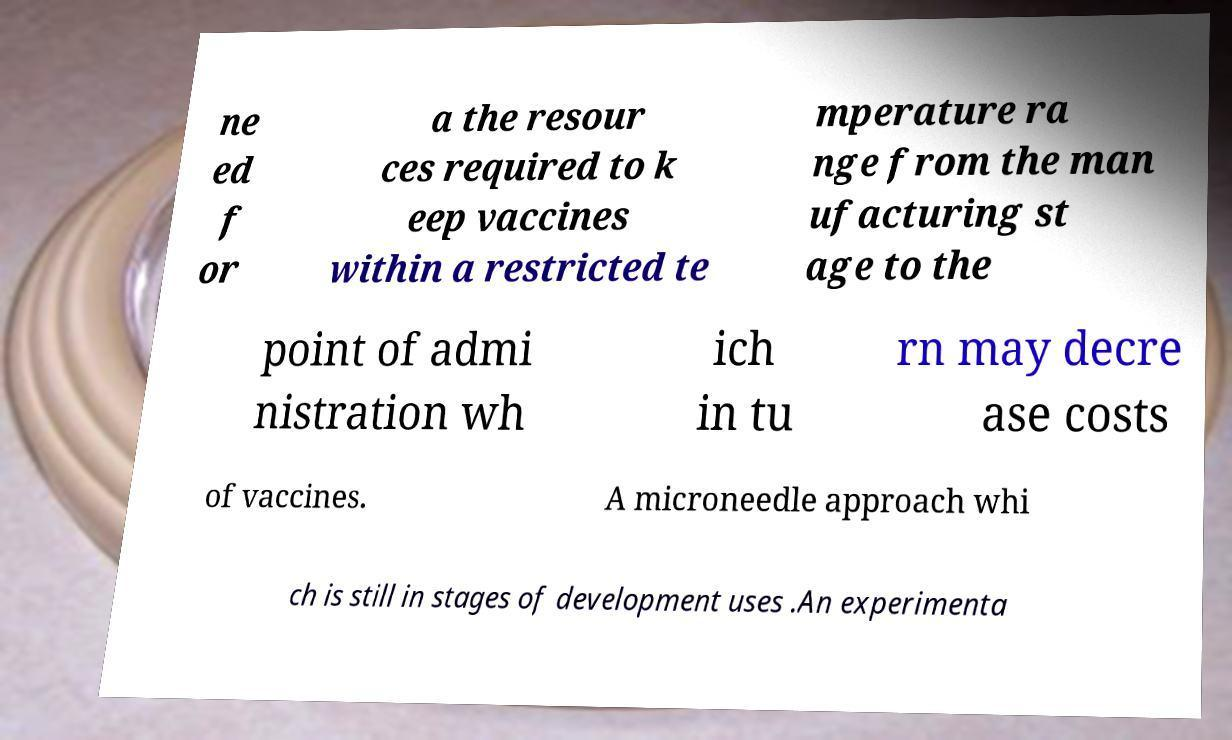Can you accurately transcribe the text from the provided image for me? ne ed f or a the resour ces required to k eep vaccines within a restricted te mperature ra nge from the man ufacturing st age to the point of admi nistration wh ich in tu rn may decre ase costs of vaccines. A microneedle approach whi ch is still in stages of development uses .An experimenta 